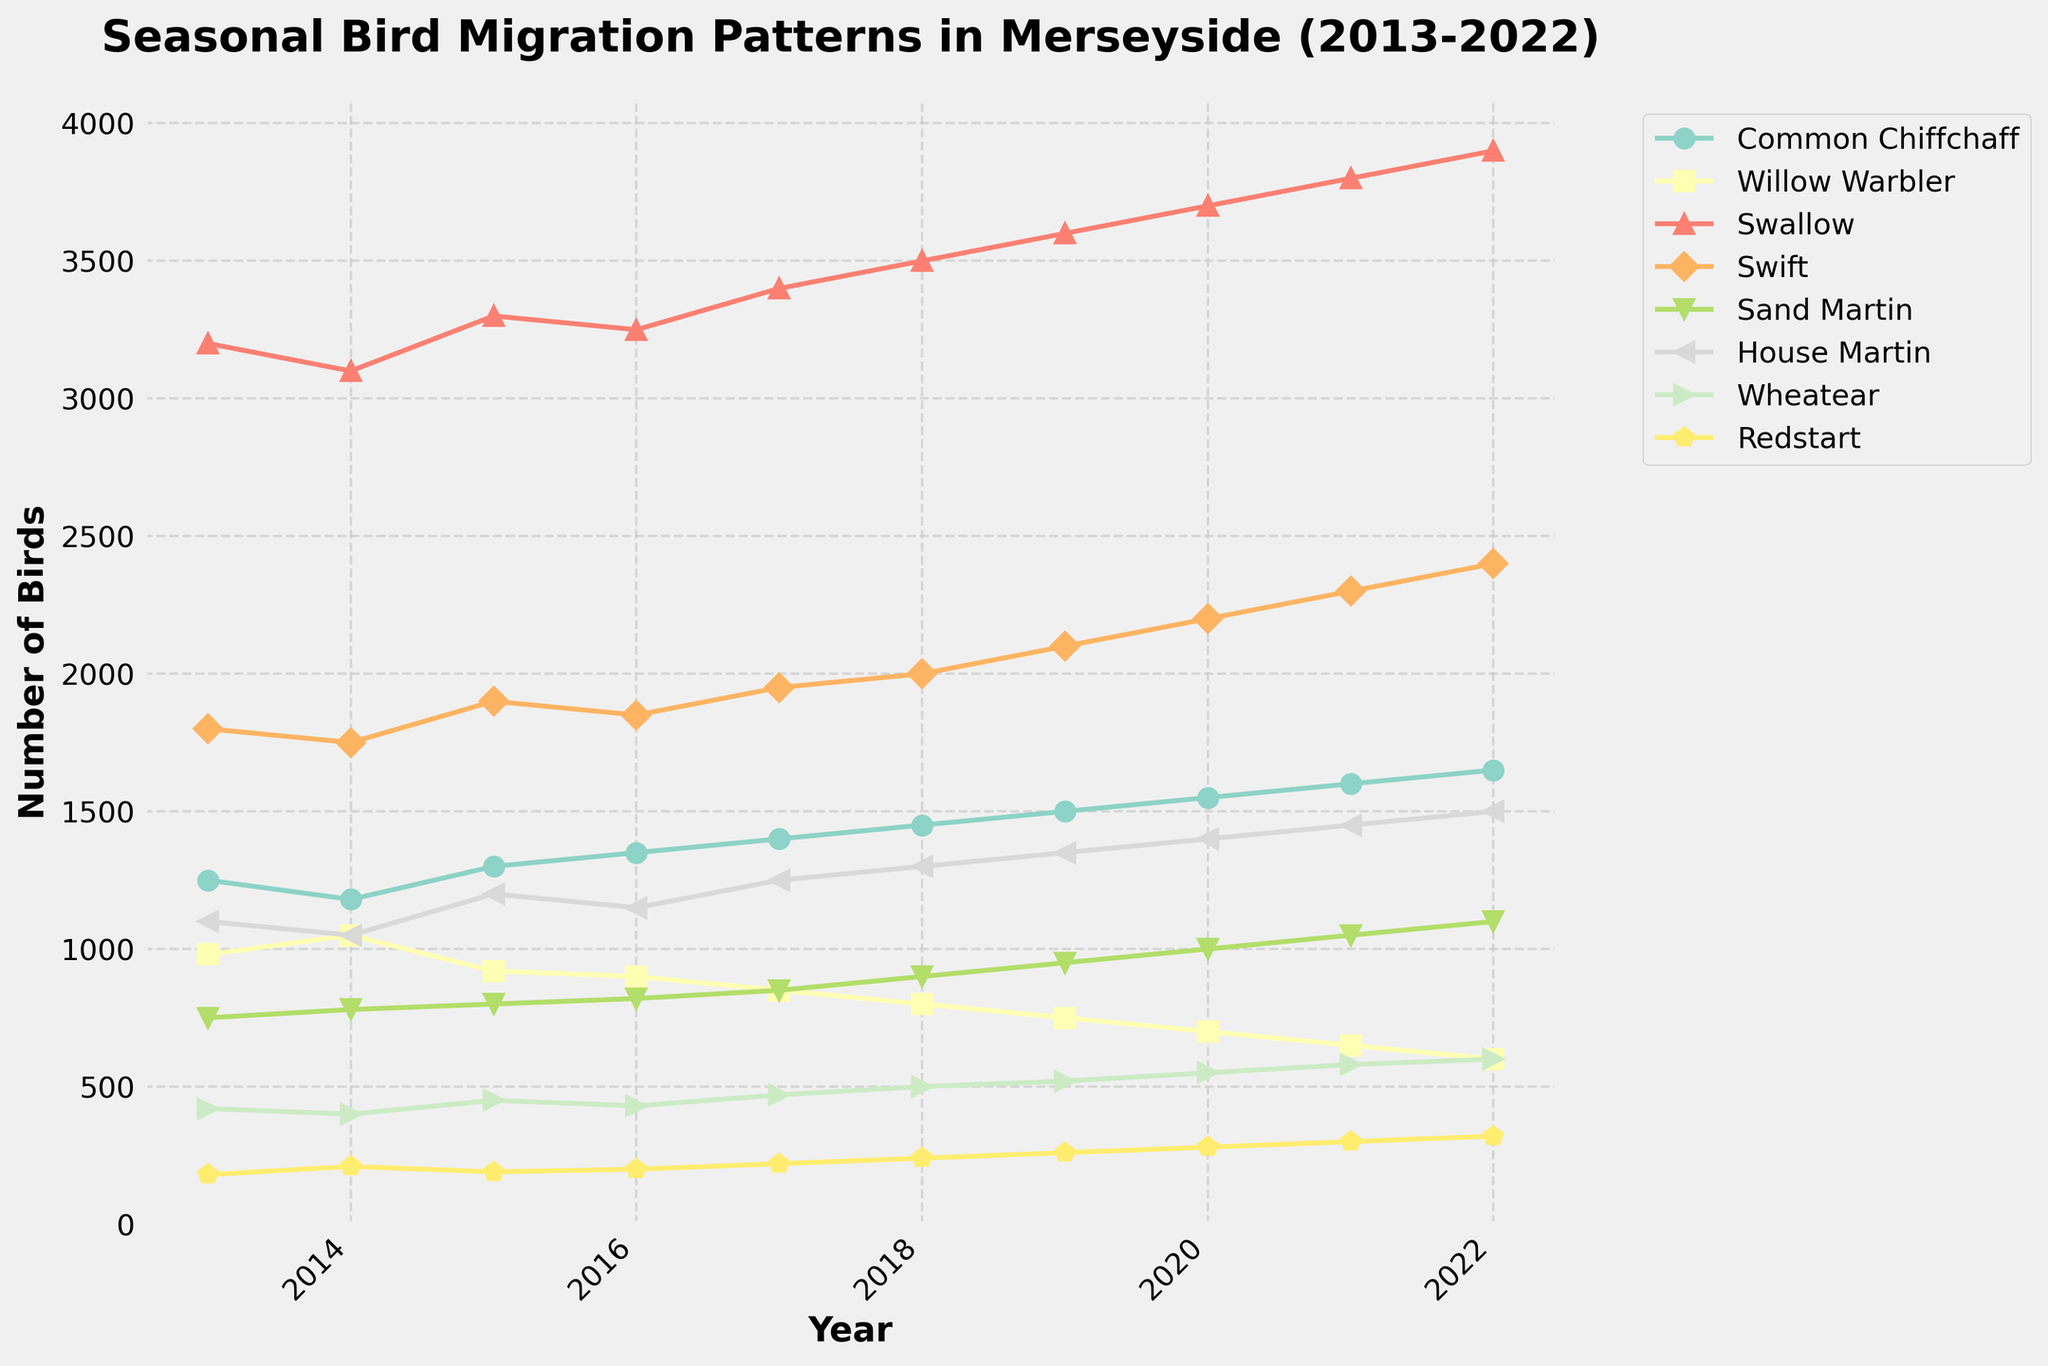What's the overall trend for the number of Swallows from 2013 to 2022? Observe the line corresponding to Swallows, which consistently rises over the years, indicating an increasing trend.
Answer: Increasing Which species had the highest number in 2022? Check the endpoints of all lines at the year 2022. Swallows have the highest value at 3900.
Answer: Swallow What is the difference in the number of House Martins between 2013 and 2022? Note the values for House Martins in 2013 (1100) and 2022 (1500), then subtract 1100 from 1500.
Answer: 400 Which two species show a decreasing trend over the period from 2013 to 2022? Identify the lines sloping downwards over the years. Common Chiffchaff and Willow Warbler both show a decreasing trend.
Answer: Common Chiffchaff, Willow Warbler In which year did the number of Swifts surpass 2000? Locate the Swift line and find the year where it first crosses the 2000 mark.
Answer: 2018 What is the total number of Redstarts observed across all years? Sum the yearly values for Redstarts from 2013 to 2022. This gives 180 + 210 + 190 + 200 + 220 + 240 + 260 + 280 + 300 + 320, which equals 2400.
Answer: 2400 Between 2016 and 2020, which species had the most significant increase in numbers? Calculate the difference for each species between these years and compare. Swallow had the largest increase from 3250 to 3700, thus 450.
Answer: Swallow Which species appears to have the most stable population with the least fluctuation over the decade? Look at the lines for each species and identify which has the least upward or downward movement. Willow Warbler appears the most stable.
Answer: Willow Warbler How does the number of Sand Martins in 2015 compare to the number of Wheatears in 2017? Check the values directly: Sand Martins in 2015 is 800, and Wheatears in 2017 is 470.
Answer: Sand Martins in 2015 are greater than Wheatears in 2017 